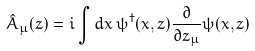Convert formula to latex. <formula><loc_0><loc_0><loc_500><loc_500>\hat { A } _ { \mu } ( z ) = i \int d x \, \psi ^ { \dagger } ( x , z ) \frac { \partial } { \partial z _ { \mu } } \psi ( x , z )</formula> 